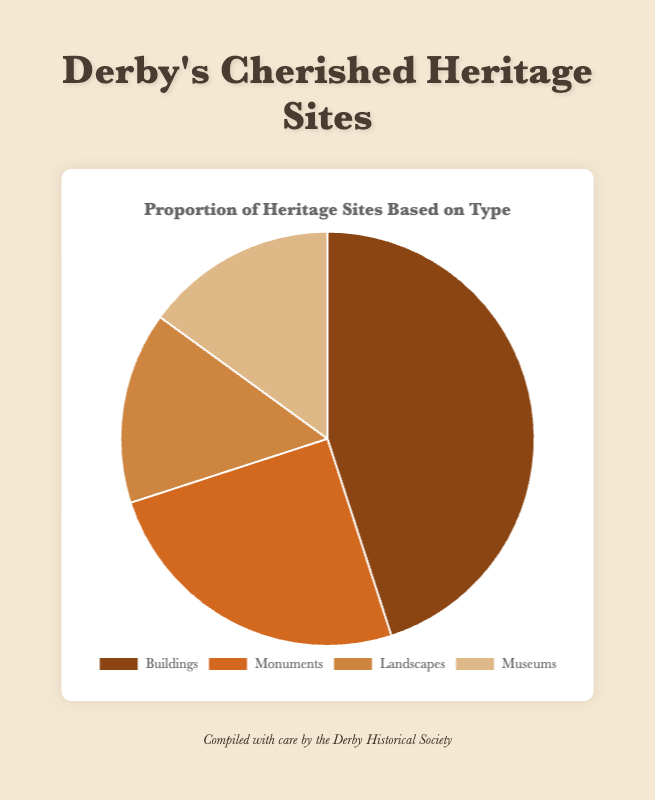Which category makes up the largest proportion of heritage sites? By looking at the size of the slices, the 'Buildings' category occupies the largest portion of the pie chart.
Answer: Buildings Which two categories together make up the smallest proportion of heritage sites? By examining the pie chart, we see that 'Landscapes' and 'Museums' slices are both 15 each, which sum up to the smallest total proportion (30) together.
Answer: Landscapes and Museums How much greater is the proportion of 'Buildings' compared to 'Monuments'? 'Buildings' have a proportion of 45, while 'Monuments' have 25. The difference is obtained by subtracting 25 from 45.
Answer: 20 What is the ratio of Buildings to the combined total of Landscapes and Museums? 'Buildings' have a proportion of 45. The combined total of 'Landscapes' and 'Museums' is 15 + 15 = 30. The ratio is 45:30, which simplifies to 3:2.
Answer: 3:2 What percentage of heritage sites are categorized as Monuments? 'Monuments' have a value of 25. The total sum of all categories is 45+25+15+15 = 100. Therefore, the percentage is (25/100) * 100%.
Answer: 25% Which segment is shaded in the darkest brown color? By visual inspection of the pie chart, the 'Buildings' category is shaded in the darkest brown color.
Answer: Buildings If 10 more sites were added to the 'Landscapes' category, how would the proportion change? Adding 10 to 'Landscapes' makes it 25. New total is 45+25+25+15 = 110. The new proportion for 'Landscapes' is (25/110) * 100% ≈ 22.73%.
Answer: 22.73% Can you list the categories in order of their proportion from largest to smallest? By looking at the size of the slices, the order from largest to smallest proportion is 'Buildings', 'Monuments', 'Landscapes', and 'Museums'.
Answer: Buildings, Monuments, Landscapes, Museums What portion of the pie chart is occupied by categories other than Buildings? 'Buildings' occupy 45, and the total is 100. Other categories sum up to 100 - 45 = 55.
Answer: 55% 